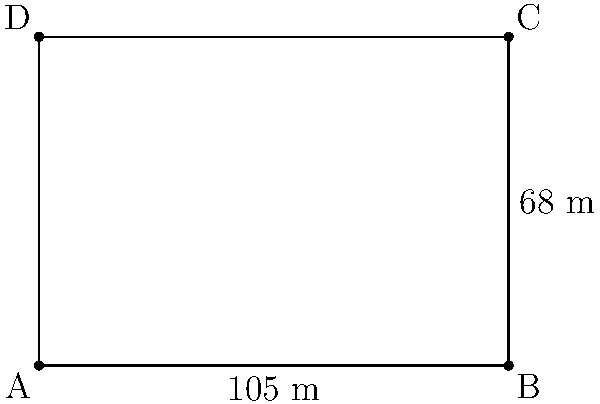A V.League soccer field has dimensions of 105 meters in length and 68 meters in width, as shown in the diagram. Calculate the total area of the field in square meters. To calculate the area of the soccer field, we need to follow these steps:

1. Identify the shape of the field:
   The soccer field is a rectangle.

2. Recall the formula for the area of a rectangle:
   $$A = l \times w$$
   where $A$ is the area, $l$ is the length, and $w$ is the width.

3. Substitute the given dimensions:
   $$A = 105 \text{ m} \times 68 \text{ m}$$

4. Perform the multiplication:
   $$A = 7,140 \text{ m}^2$$

Therefore, the total area of the V.League soccer field is 7,140 square meters.
Answer: 7,140 m² 